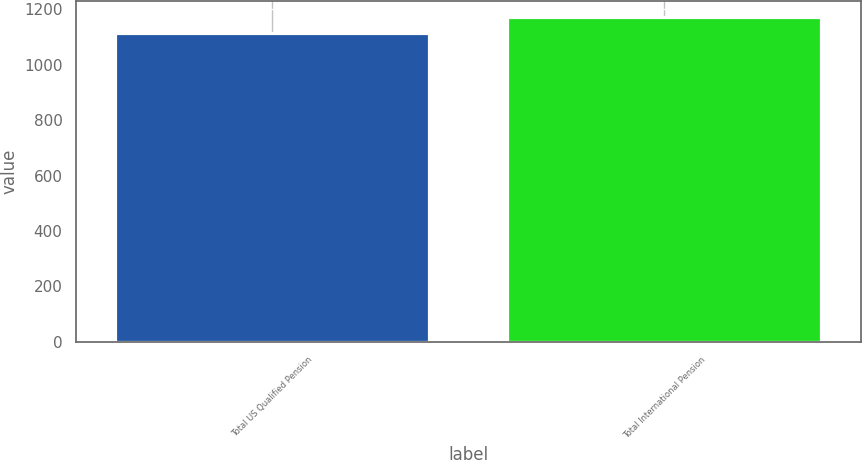Convert chart to OTSL. <chart><loc_0><loc_0><loc_500><loc_500><bar_chart><fcel>Total US Qualified Pension<fcel>Total International Pension<nl><fcel>1116<fcel>1172<nl></chart> 